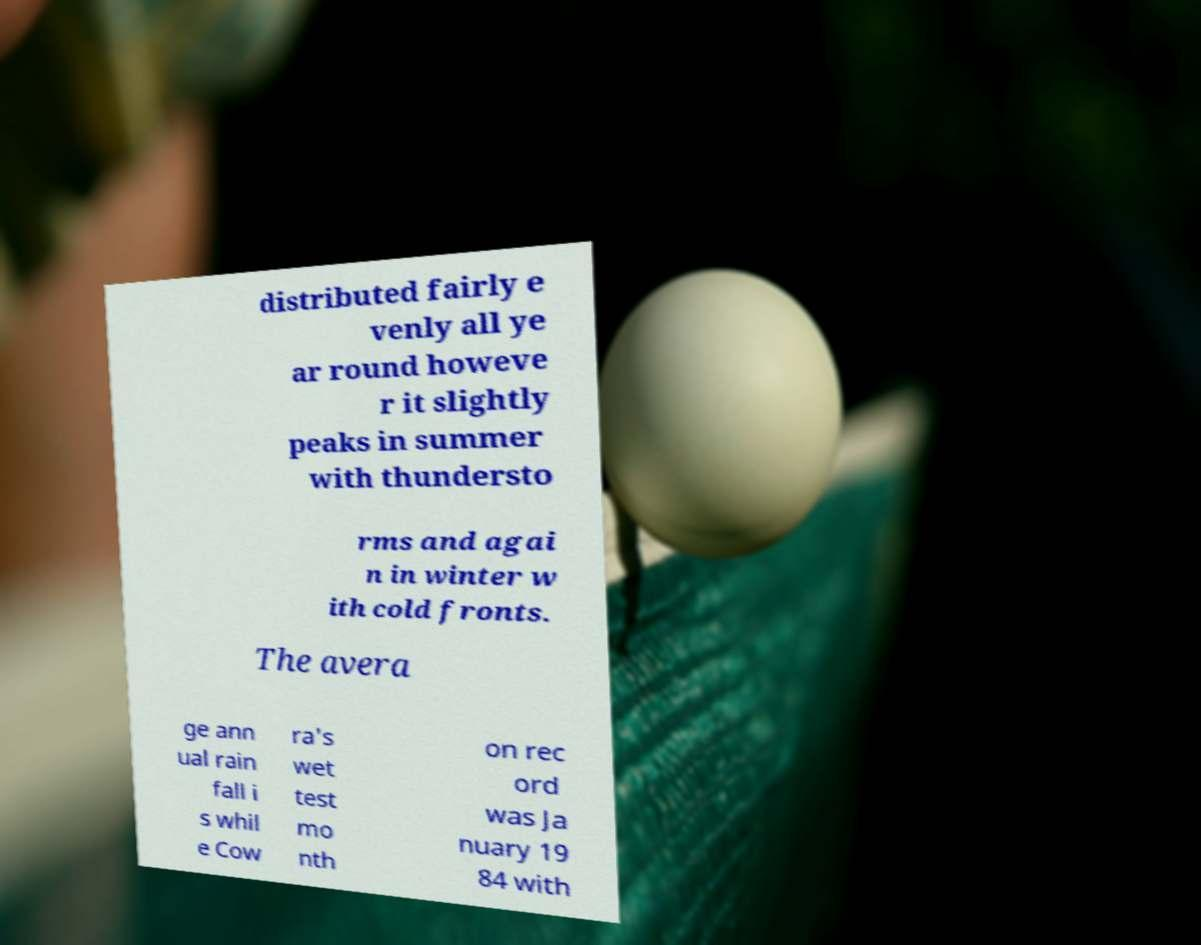For documentation purposes, I need the text within this image transcribed. Could you provide that? distributed fairly e venly all ye ar round howeve r it slightly peaks in summer with thundersto rms and agai n in winter w ith cold fronts. The avera ge ann ual rain fall i s whil e Cow ra's wet test mo nth on rec ord was Ja nuary 19 84 with 